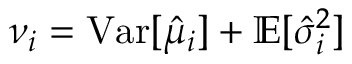Convert formula to latex. <formula><loc_0><loc_0><loc_500><loc_500>\nu _ { i } = V a r [ \hat { \mu } _ { i } ] + \mathbb { E } [ \hat { \sigma } _ { i } ^ { 2 } ]</formula> 